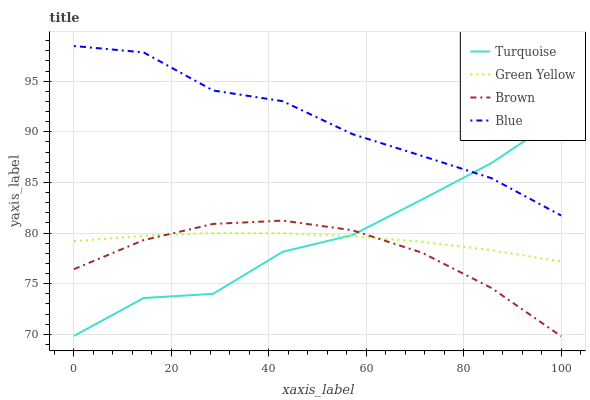Does Brown have the minimum area under the curve?
Answer yes or no. Yes. Does Blue have the maximum area under the curve?
Answer yes or no. Yes. Does Turquoise have the minimum area under the curve?
Answer yes or no. No. Does Turquoise have the maximum area under the curve?
Answer yes or no. No. Is Green Yellow the smoothest?
Answer yes or no. Yes. Is Turquoise the roughest?
Answer yes or no. Yes. Is Brown the smoothest?
Answer yes or no. No. Is Brown the roughest?
Answer yes or no. No. Does Brown have the lowest value?
Answer yes or no. Yes. Does Turquoise have the lowest value?
Answer yes or no. No. Does Blue have the highest value?
Answer yes or no. Yes. Does Brown have the highest value?
Answer yes or no. No. Is Green Yellow less than Blue?
Answer yes or no. Yes. Is Blue greater than Brown?
Answer yes or no. Yes. Does Turquoise intersect Brown?
Answer yes or no. Yes. Is Turquoise less than Brown?
Answer yes or no. No. Is Turquoise greater than Brown?
Answer yes or no. No. Does Green Yellow intersect Blue?
Answer yes or no. No. 